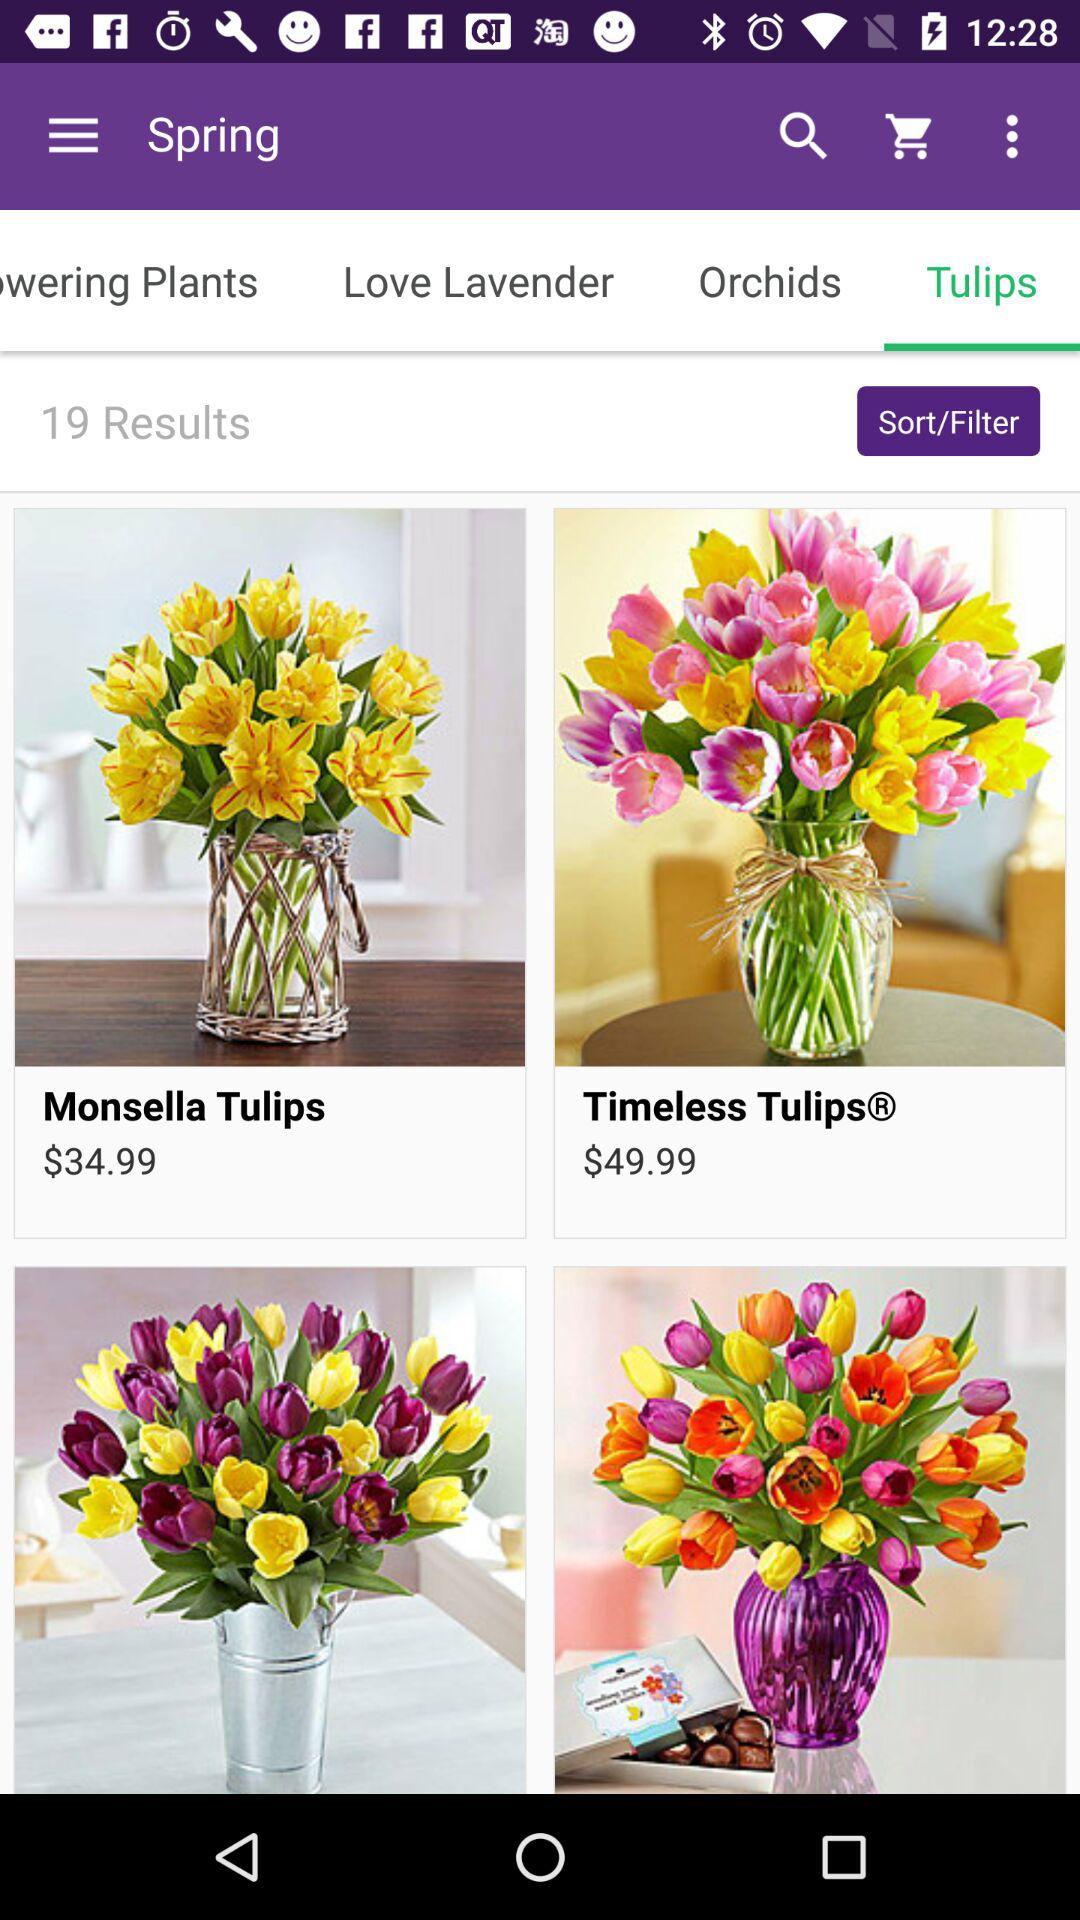How many results are there for the search term "Spring"
Answer the question using a single word or phrase. 19 